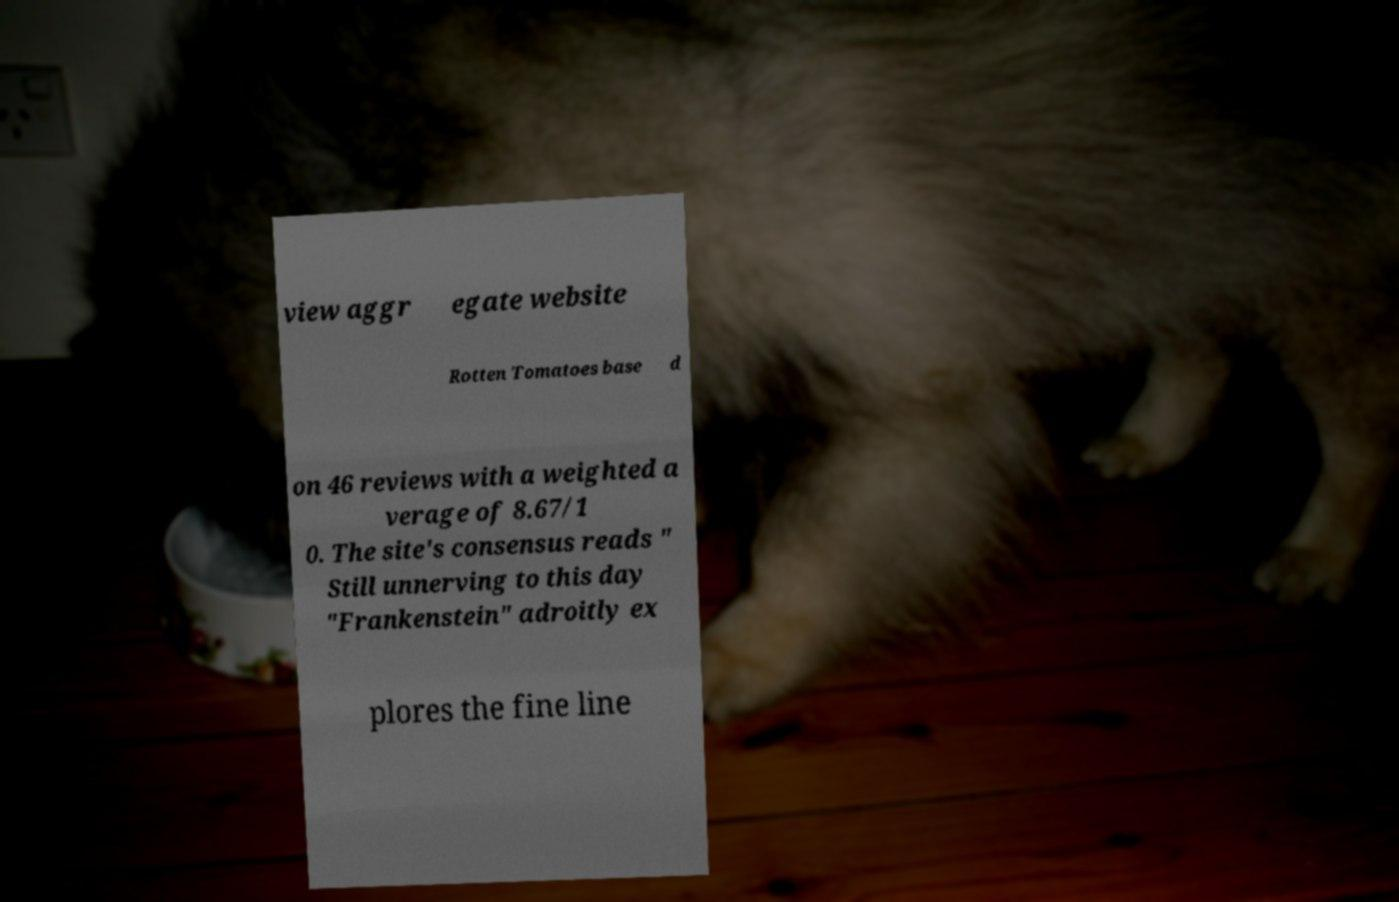What messages or text are displayed in this image? I need them in a readable, typed format. view aggr egate website Rotten Tomatoes base d on 46 reviews with a weighted a verage of 8.67/1 0. The site's consensus reads " Still unnerving to this day "Frankenstein" adroitly ex plores the fine line 